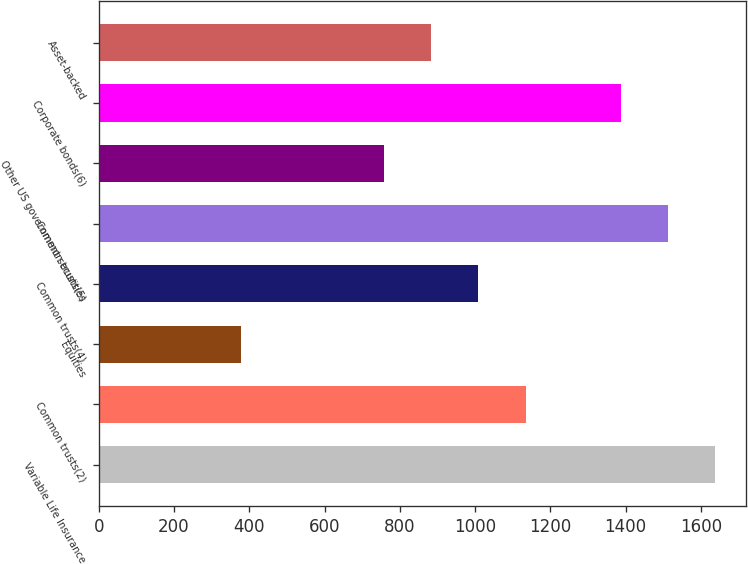Convert chart to OTSL. <chart><loc_0><loc_0><loc_500><loc_500><bar_chart><fcel>Variable Life Insurance<fcel>Common trusts(2)<fcel>Equities<fcel>Common trusts(4)<fcel>Common trusts(5)<fcel>Other US government securities<fcel>Corporate bonds(6)<fcel>Asset-backed<nl><fcel>1638.99<fcel>1134.99<fcel>378.99<fcel>1008.99<fcel>1512.99<fcel>756.99<fcel>1386.99<fcel>882.99<nl></chart> 